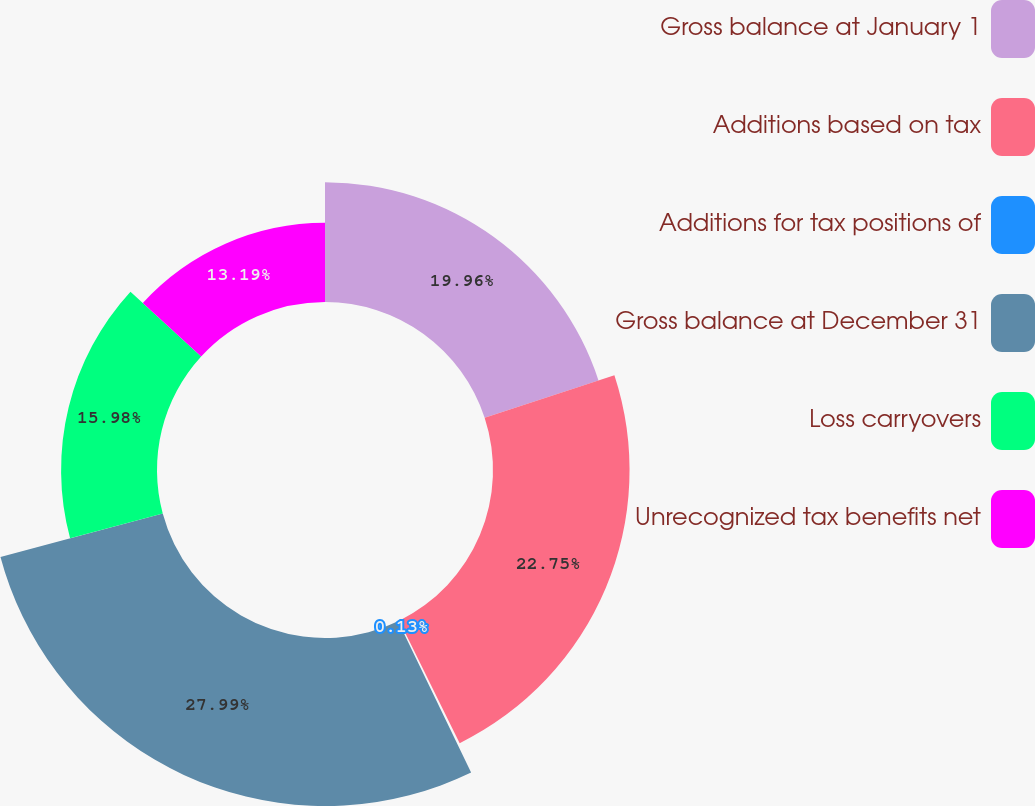Convert chart. <chart><loc_0><loc_0><loc_500><loc_500><pie_chart><fcel>Gross balance at January 1<fcel>Additions based on tax<fcel>Additions for tax positions of<fcel>Gross balance at December 31<fcel>Loss carryovers<fcel>Unrecognized tax benefits net<nl><fcel>19.96%<fcel>22.75%<fcel>0.13%<fcel>27.99%<fcel>15.98%<fcel>13.19%<nl></chart> 